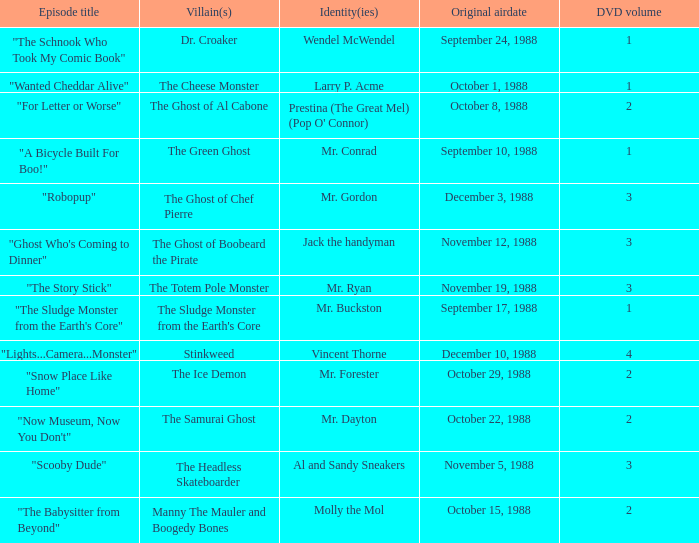Name the episode that aired october 8, 1988 "For Letter or Worse". 